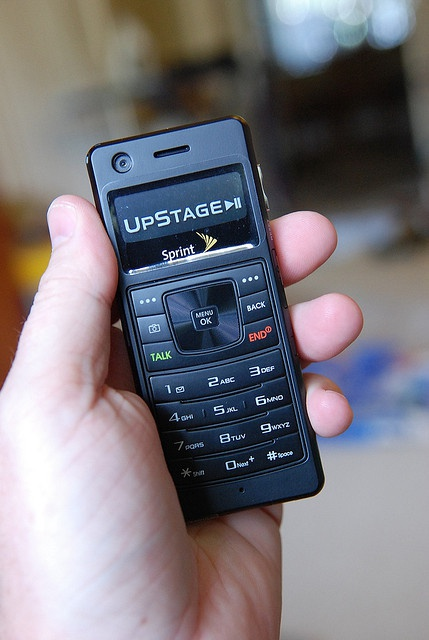Describe the objects in this image and their specific colors. I can see people in gray, lavender, darkgray, and brown tones and cell phone in gray, black, navy, and blue tones in this image. 